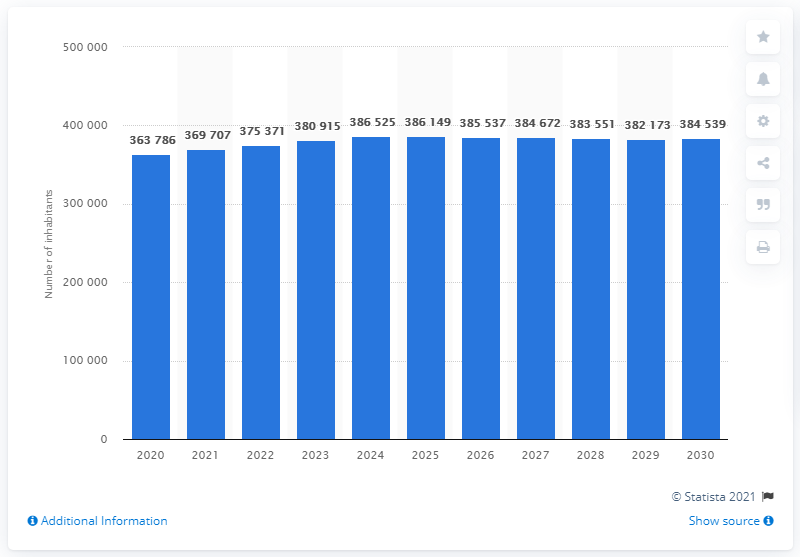How does the population growth rate from 2020 to 2030 compare with previous decades? The growth rate from 2020 to 2030 appears to be more uniform and stable compared to previous decades, which might have seen more fluctuations due to various economic and social changes globally and nationally. 